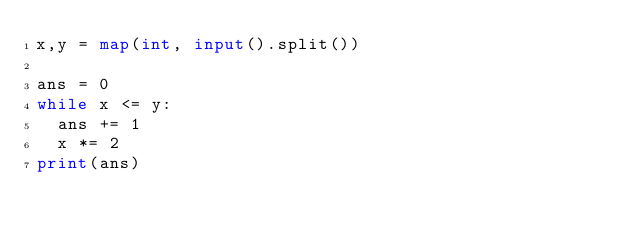<code> <loc_0><loc_0><loc_500><loc_500><_Python_>x,y = map(int, input().split())

ans = 0
while x <= y:
  ans += 1
  x *= 2
print(ans)</code> 